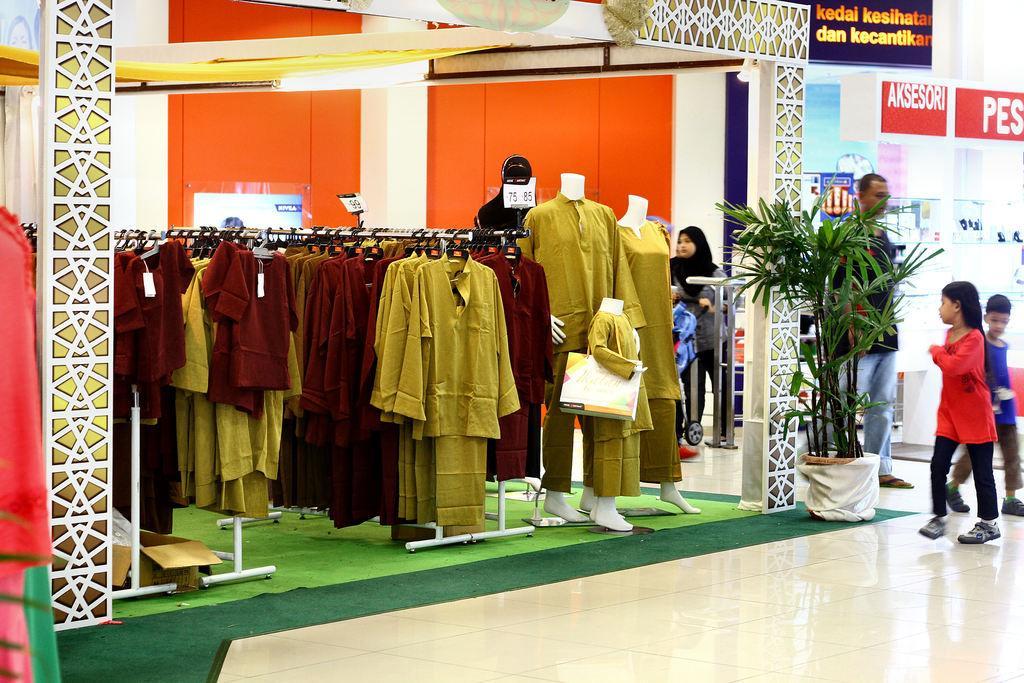Describe this image in one or two sentences. In this image I can see few clothes are hanged to the poles. I can see few dresses to the mannequins. I can see the flowerpot, cardboard boxes, boards, few people and the store. 